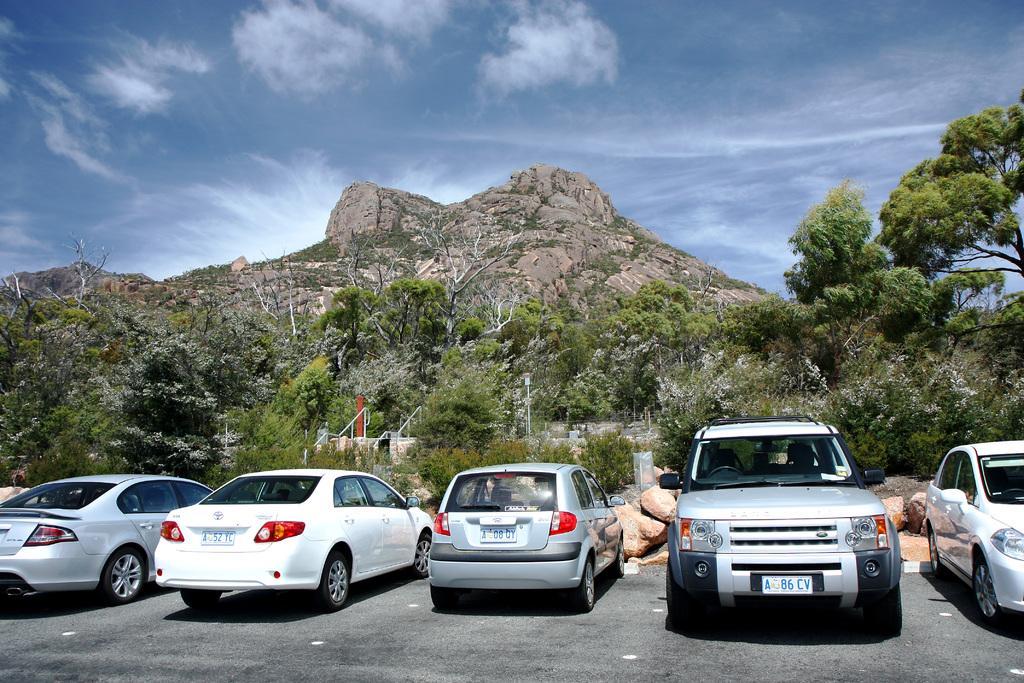Describe this image in one or two sentences. In the foreground of this image, there are cars parked side to the road. In the background, we can see trees, poles, mountain, sky and the cloud. 